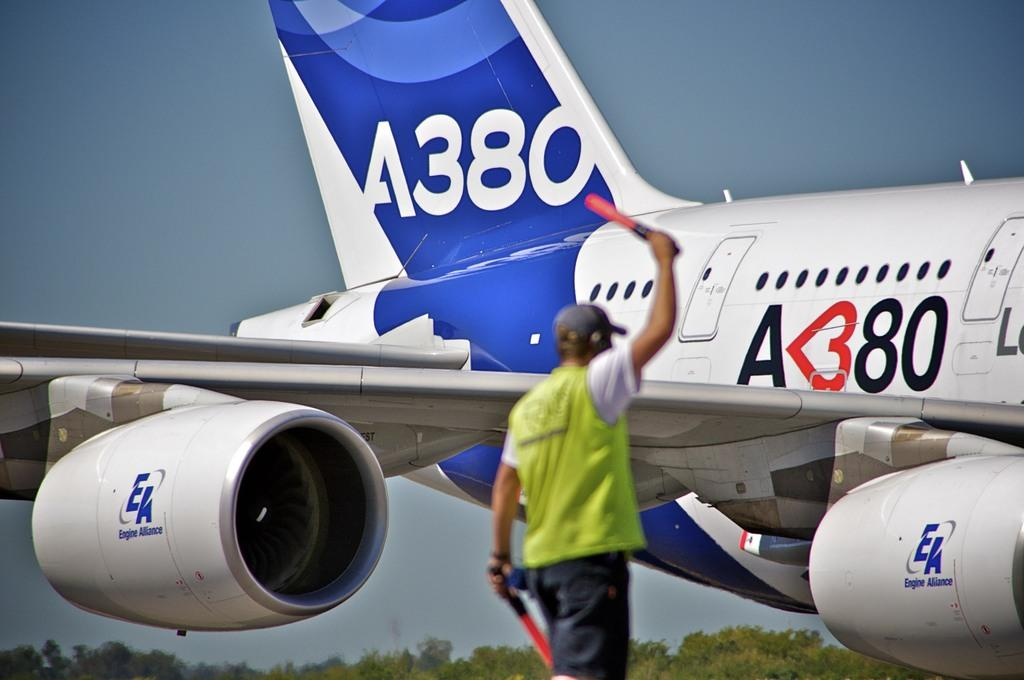What is the main subject of the image? There is a man in the image. What is the man doing in the image? The man is standing in the image. What is the man holding in his hands? The man is holding objects in his hands. What can be seen in the background of the image? There is an aeroplane, trees, and the sky visible in the background of the image. What type of cream can be seen on the frame of the aeroplane in the man is holding? There is no frame or aeroplane visible in the man's hands in the image, and therefore no cream can be seen on it. What type of spade is the man using to dig in the background of the image? There is no spade or digging activity visible in the image; the man is simply standing with objects in his hands. 